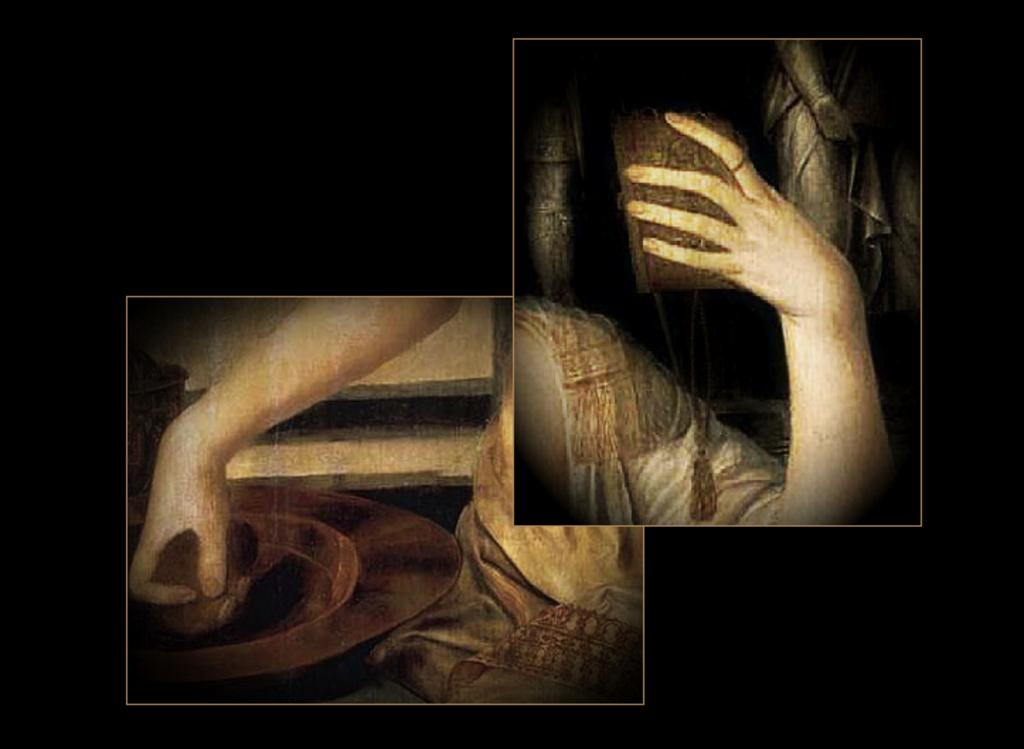How many paintings are visible in the image? There are two paintings in the image. What is happening in the first painting? In the first painting, a human hand is holding an object. What can be seen in the second painting? In the second painting, there is a person and an object. What is the aftermath of the brothers' argument in the image? There are no brothers or any argument depicted in the image; it only features two paintings. 